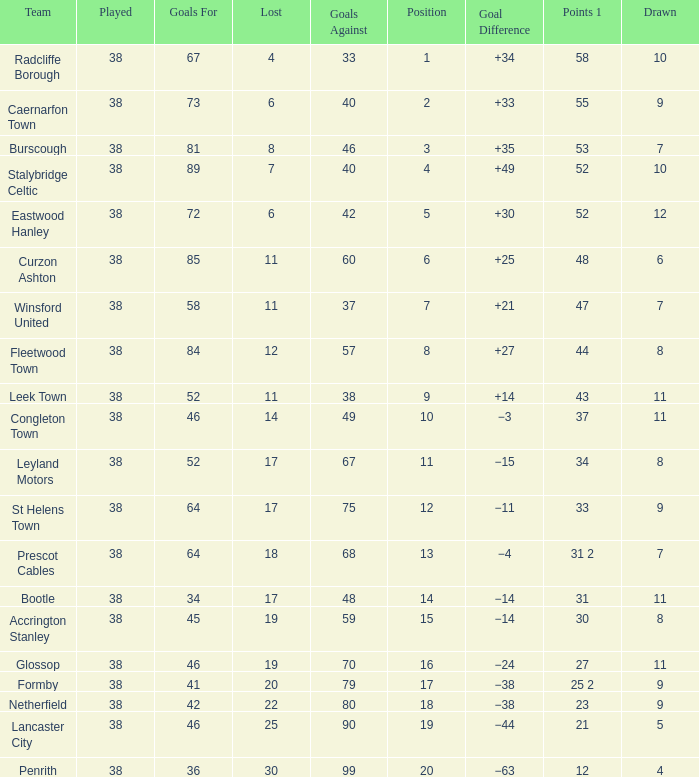WHAT IS THE POSITION WITH A LOST OF 6, FOR CAERNARFON TOWN? 2.0. 